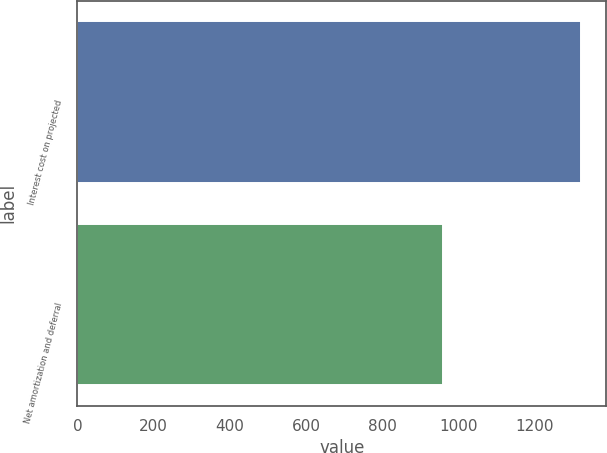Convert chart. <chart><loc_0><loc_0><loc_500><loc_500><bar_chart><fcel>Interest cost on projected<fcel>Net amortization and deferral<nl><fcel>1321<fcel>958<nl></chart> 